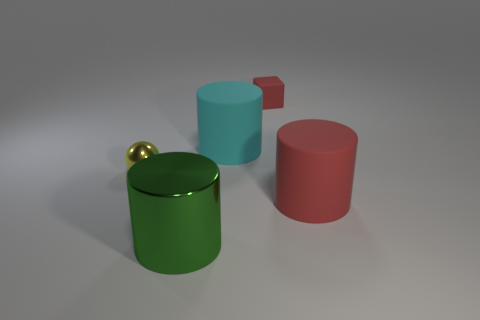There is a rubber cylinder that is in front of the cyan cylinder; is its size the same as the red thing that is behind the tiny yellow ball?
Provide a short and direct response. No. What color is the matte cylinder that is left of the matte object on the right side of the small object that is right of the yellow metal ball?
Provide a succinct answer. Cyan. Are there any other big cyan objects of the same shape as the large metal object?
Offer a very short reply. Yes. Is the number of things on the left side of the big green thing greater than the number of gray shiny spheres?
Your response must be concise. Yes. What number of metallic objects are either blue spheres or tiny blocks?
Offer a very short reply. 0. There is a object that is left of the cyan rubber cylinder and behind the large green object; how big is it?
Provide a succinct answer. Small. There is a shiny thing that is behind the large metal thing; are there any green shiny cylinders that are right of it?
Provide a succinct answer. Yes. There is a big metallic object; how many cylinders are behind it?
Your answer should be very brief. 2. There is a big shiny thing that is the same shape as the cyan rubber thing; what is its color?
Your answer should be very brief. Green. Are the small object to the right of the shiny sphere and the tiny thing that is in front of the small red cube made of the same material?
Offer a very short reply. No. 